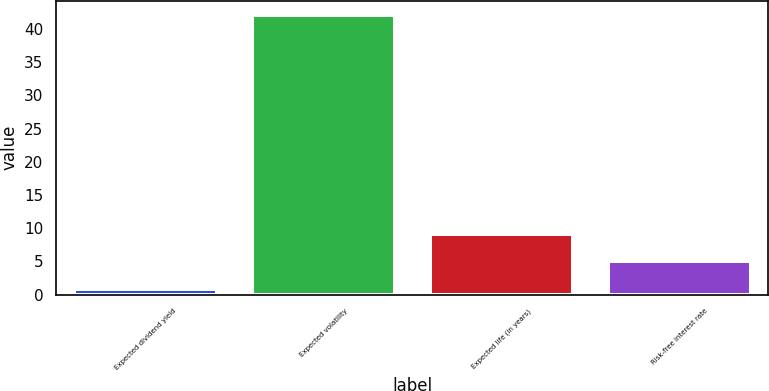Convert chart. <chart><loc_0><loc_0><loc_500><loc_500><bar_chart><fcel>Expected dividend yield<fcel>Expected volatility<fcel>Expected life (in years)<fcel>Risk-free interest rate<nl><fcel>0.87<fcel>42.17<fcel>9.13<fcel>5<nl></chart> 